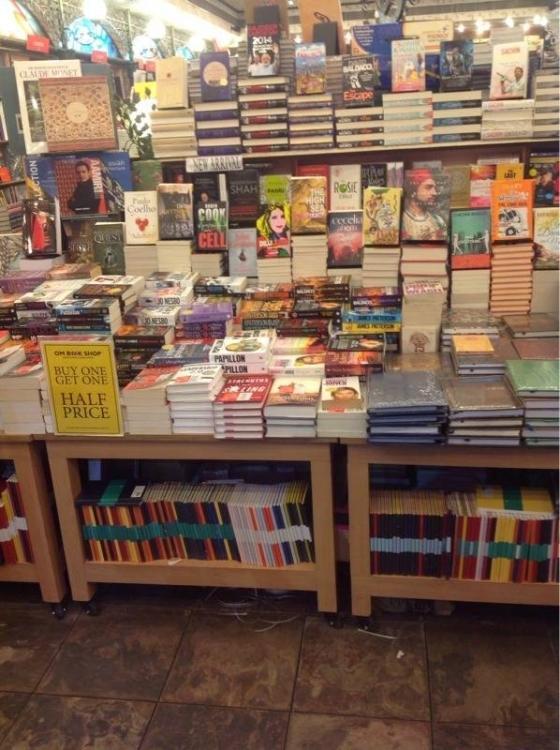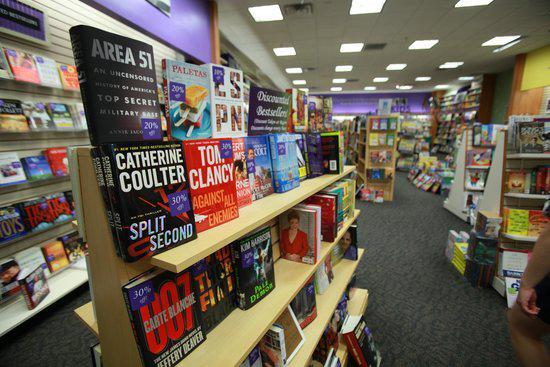The first image is the image on the left, the second image is the image on the right. Given the left and right images, does the statement "Two images on the left show the outside store front of a book shop." hold true? Answer yes or no. No. The first image is the image on the left, the second image is the image on the right. Assess this claim about the two images: "Contains a photo of the book store from outside the shop.". Correct or not? Answer yes or no. No. 